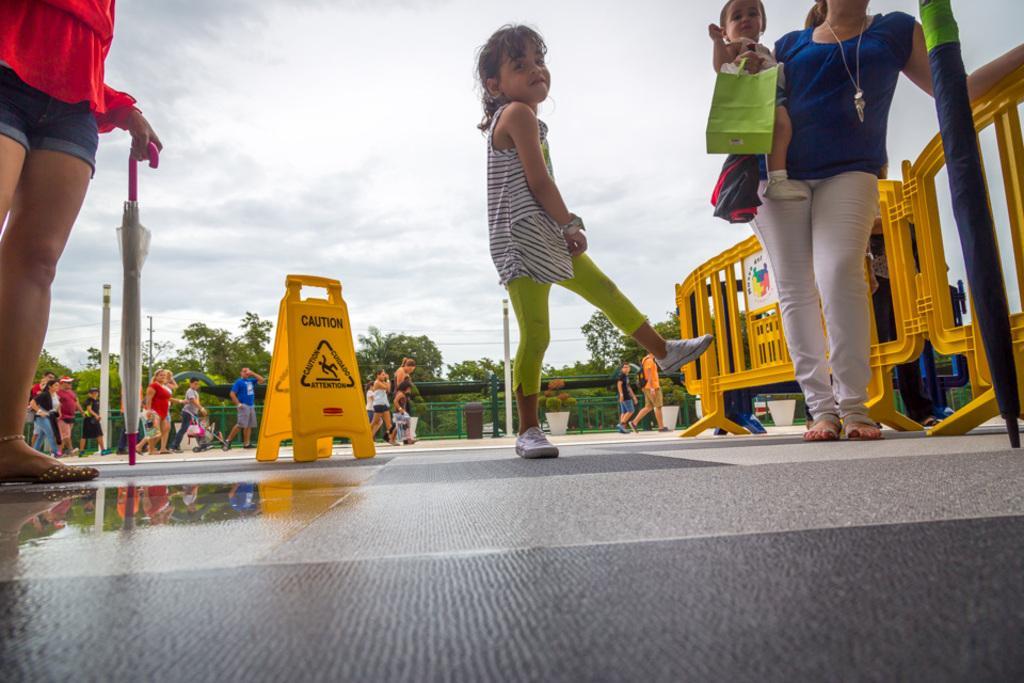How would you summarize this image in a sentence or two? In this picture we can see a group of people were some are standing and some are walking on the road, umbrellas, trees, bag, fence, caution board, in, pots with plants, poles and in the background we can see the sky with clouds. 